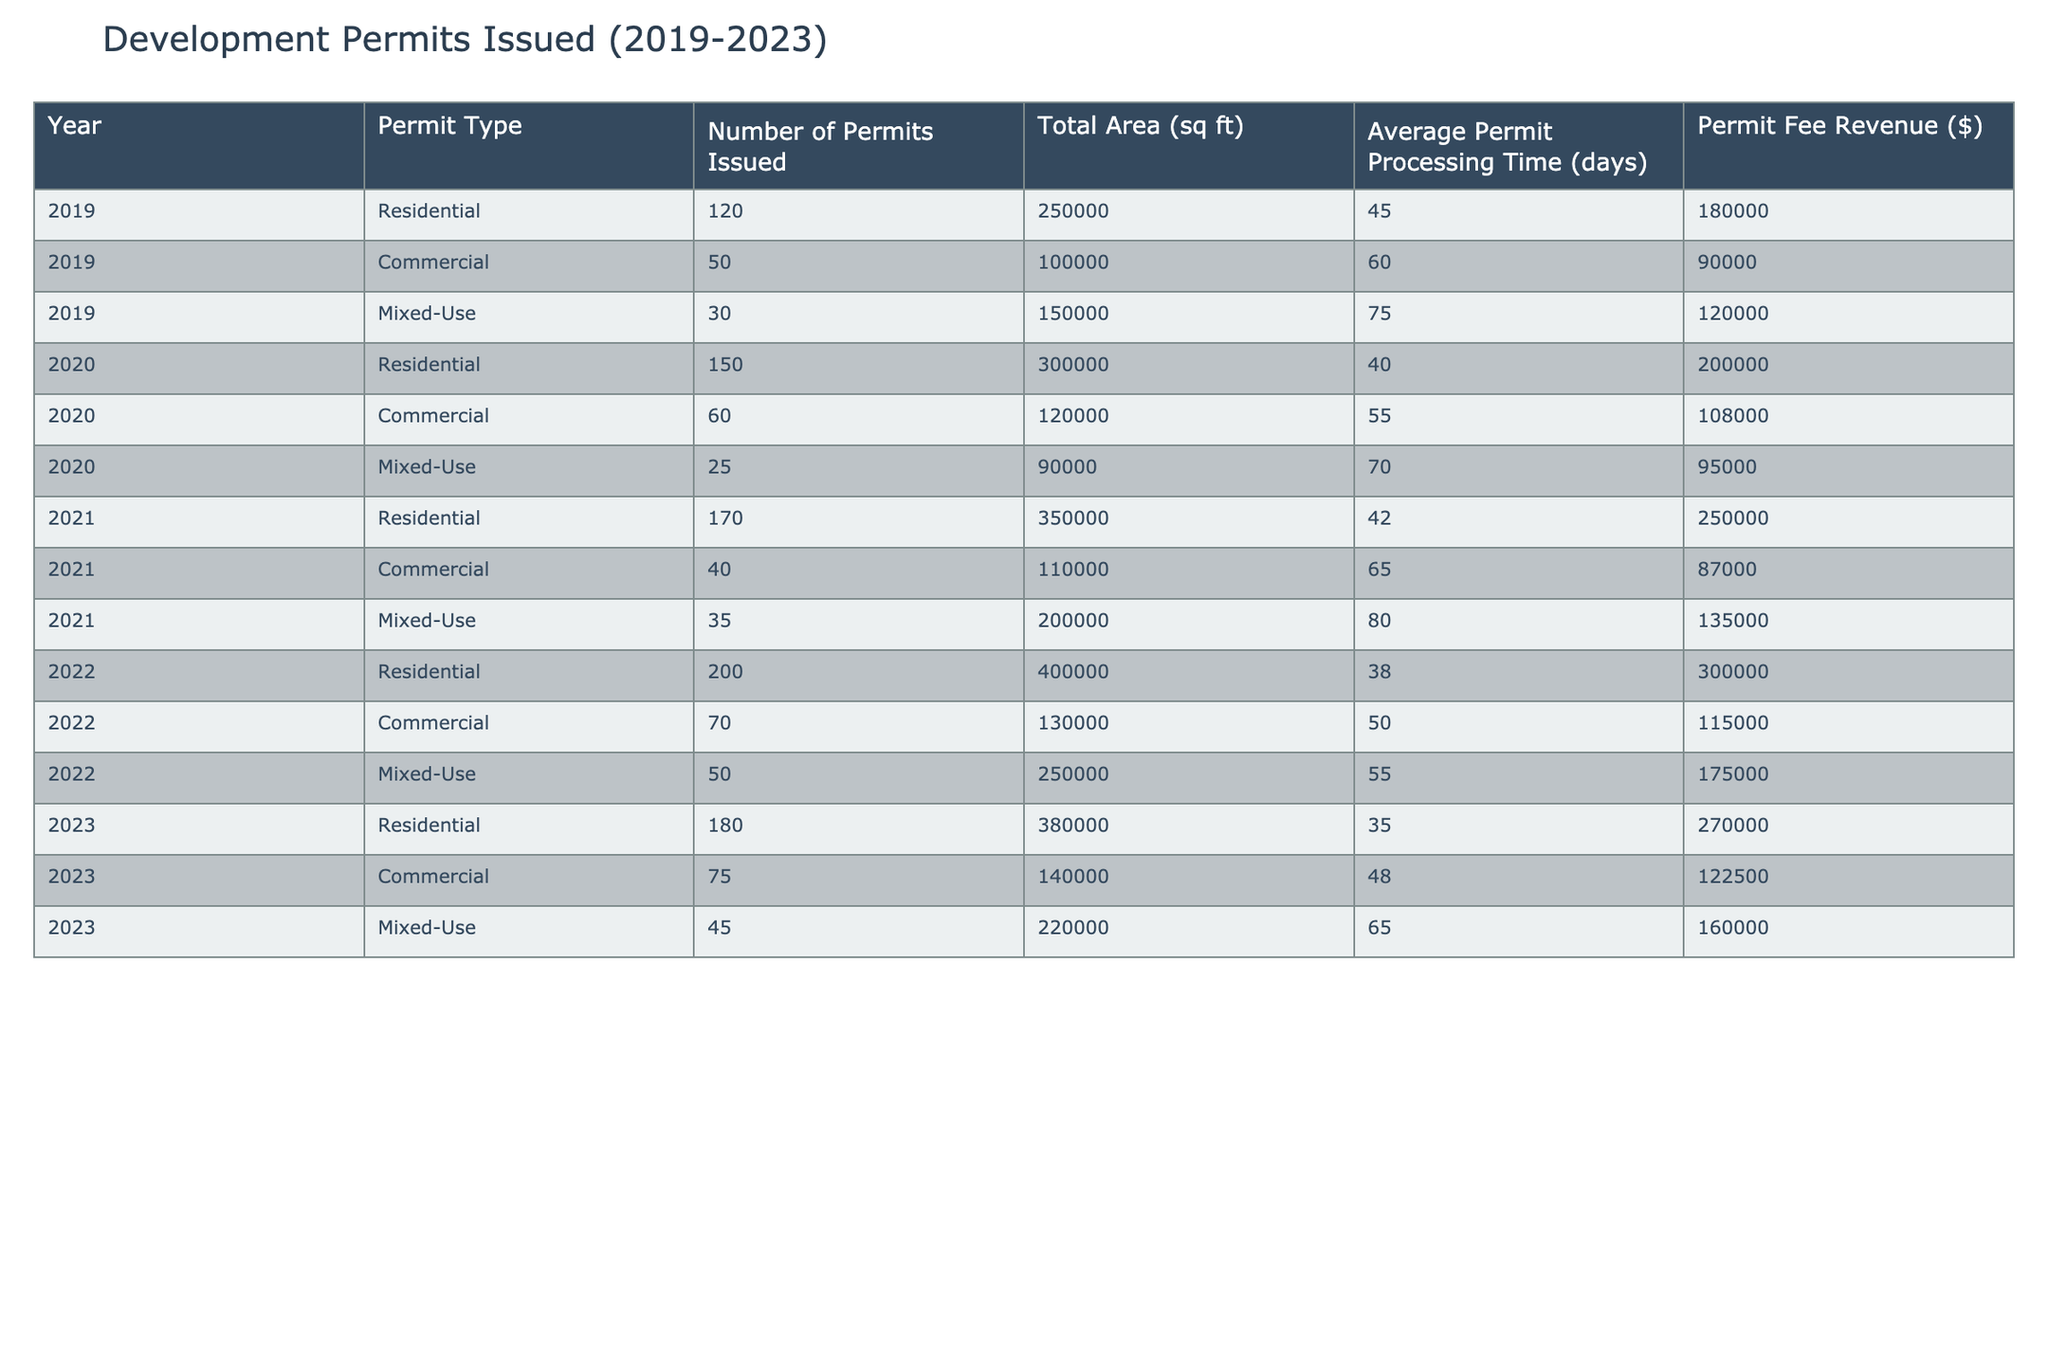What was the total number of residential permits issued in 2021? In 2021, the table shows that 170 residential permits were issued.
Answer: 170 How much permit fee revenue was generated from commercial permits in 2022? In 2022, the table indicates that the permit fee revenue from commercial permits was $115,000.
Answer: $115,000 What is the average processing time for mixed-use permits issued in 2020 and 2021? The table lists the average processing time for mixed-use permits as 70 days in 2020 and 80 days in 2021. To find the average, we sum these two values: 70 + 80 = 150 days, then divide by 2: 150/2 = 75 days.
Answer: 75 Was there an increase in the number of residential permits issued from 2019 to 2023? In 2019, 120 residential permits were issued, and in 2023, 180 were issued, so there was an increase.
Answer: Yes What was the total area covered by commercial permits issued over the five years? The total area from commercial permits is calculated by adding the values: 100,000 (2019) + 120,000 (2020) + 110,000 (2021) + 130,000 (2022) + 140,000 (2023) = 600,000 sq ft.
Answer: 600,000 sq ft How does the average processing time for residential permits in 2022 compare to that in 2023? The average processing time for residential permits in 2022 was 38 days, and in 2023 it was 35 days, indicating a reduction in time.
Answer: Decreased What was the ratio of the number of mixed-use permits issued in 2022 to those issued in 2020? In 2022, 50 mixed-use permits were issued, and in 2020, 25 were issued. To find the ratio, we divide: 50/25 = 2.
Answer: 2 Which year had the highest total area for residential permits? The table shows that 2022 had the highest total area for residential permits at 400,000 sq ft.
Answer: 2022 Was the total permit fee revenue from mixed-use permits higher in 2021 or 2022? In 2021, the revenue from mixed-use permits was $135,000, while in 2022, it was $175,000. Since $175,000 is greater than $135,000, 2022 had higher revenue.
Answer: 2022 